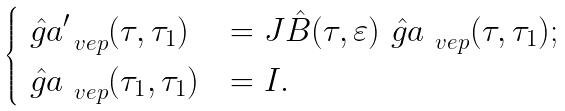<formula> <loc_0><loc_0><loc_500><loc_500>\begin{cases} \hat { \ g a } ^ { \prime } _ { \ v e p } ( \tau , \tau _ { 1 } ) & = J \hat { B } ( \tau , \varepsilon ) \hat { \ g a } _ { \ v e p } ( \tau , \tau _ { 1 } ) ; \\ \hat { \ g a } _ { \ v e p } ( \tau _ { 1 } , \tau _ { 1 } ) & = I . \end{cases}</formula> 